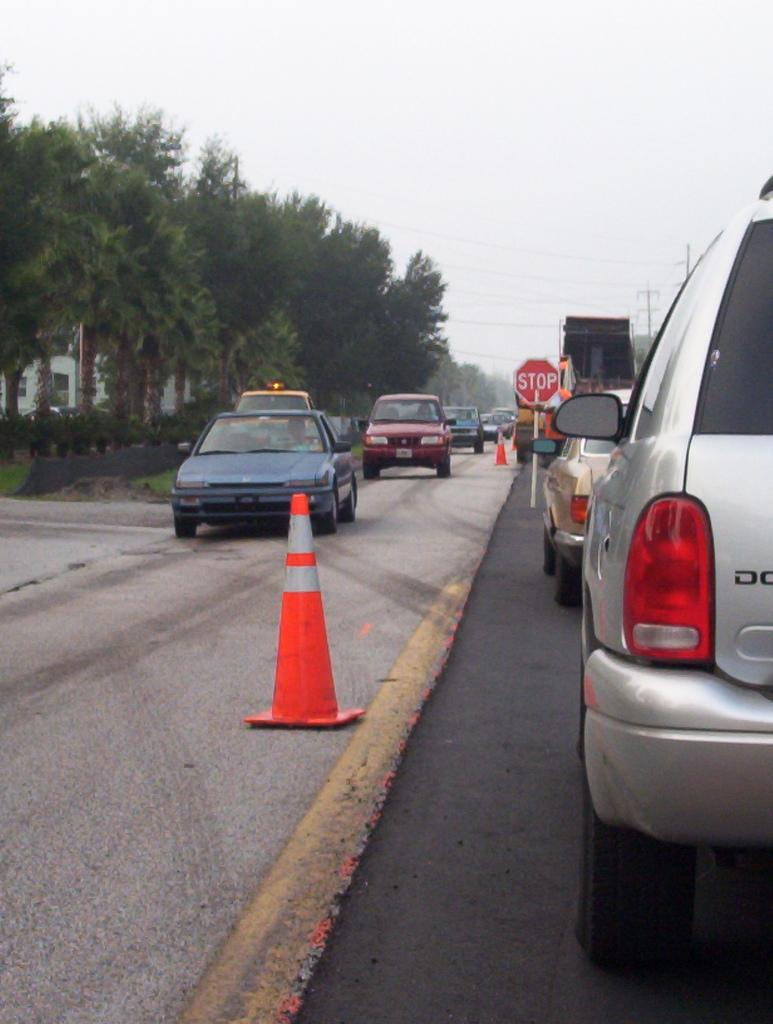What can be seen on the road in the image? There is a group of cars parked on the road. What is visible in the background of the image? There is a group of trees, poles, a sign board, and the sky in the background. How many objects can be seen in the background? There are four objects visible in the background: trees, poles, a sign board, and the sky. What type of account is being discussed on the sign board in the image? There is no sign of an account or any financial discussion on the sign board in the image. What type of cub is present in the image? There is no cub present in the image. 